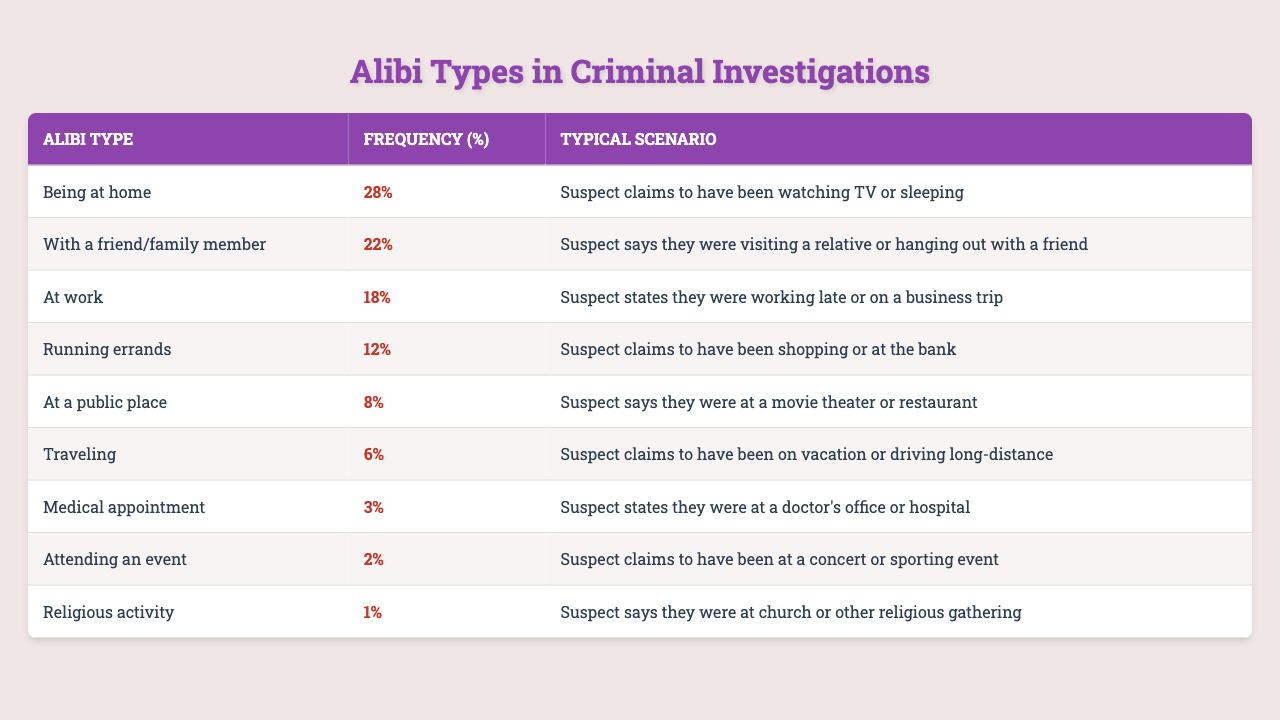What is the most common alibi type used by suspects in criminal investigations? By looking at the "Frequency (%)" column, "Being at home" has the highest percentage at 28%.
Answer: Being at home How many suspects claimed they were with a friend or family member? The frequency percentage for "With a friend/family member" is 22%, meaning 22 out of 100 suspects used this alibi type.
Answer: 22% What alibi type has the lowest frequency? The table shows that "Religious activity" has the lowest frequency at 1%.
Answer: Religious activity What is the total frequency percentage of alibi types related to activities outside of the home (at work, running errands, at a public place, traveling, medical appointment, attending an event, religious activity)? Summing up these percentages gives: 18% (at work) + 12% (running errands) + 8% (at a public place) + 6% (traveling) + 3% (medical appointment) + 2% (attending an event) + 1% (religious activity) = 50%.
Answer: 50% If we were to group the alibi types into "home-based" and "out-of-home" categories, what percentage of alibis would fall into the "home-based" category? Home-based alibis include "Being at home" (28%) and "With a friend/family member" (22%), totaling 28% + 22% = 50%.
Answer: 50% Is it true that "Traveling" is more common than "At a public place"? "Traveling" has a frequency of 6% while "At a public place" has 8%. Since 6% is less than 8%, the statement is false.
Answer: No What percentage of suspects claimed alibis related to work or medical appointments? Adding the percentages for "At work" (18%) and "Medical appointment" (3%) gives 18% + 3% = 21%.
Answer: 21% What is the difference in frequency percentage between the alibi types "Running errands" and "Medical appointment"? The frequency percentage for "Running errands" is 12% and for "Medical appointment" it is 3%. The difference is 12% - 3% = 9%.
Answer: 9% What percentage of suspects were accounted for with alibis related to attending events and religious activities combined? Adding the frequencies for "Attending an event" (2%) and "Religious activity" (1%) gives a total of 2% + 1% = 3%.
Answer: 3% 